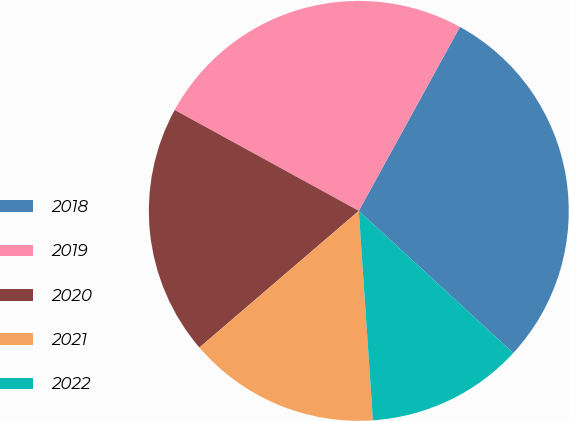Convert chart. <chart><loc_0><loc_0><loc_500><loc_500><pie_chart><fcel>2018<fcel>2019<fcel>2020<fcel>2021<fcel>2022<nl><fcel>28.84%<fcel>25.02%<fcel>19.26%<fcel>14.79%<fcel>12.09%<nl></chart> 